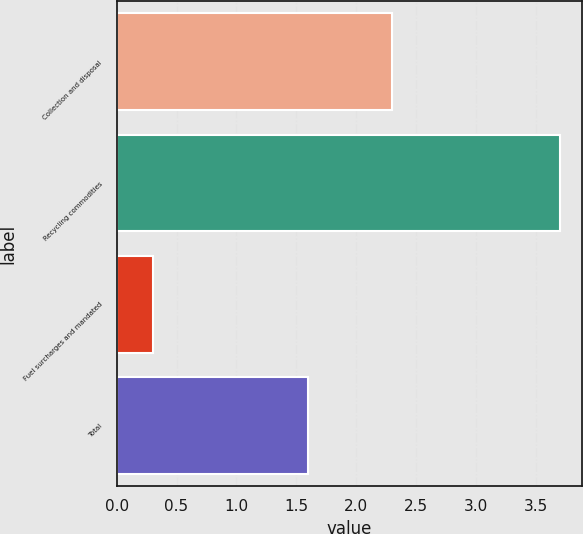Convert chart to OTSL. <chart><loc_0><loc_0><loc_500><loc_500><bar_chart><fcel>Collection and disposal<fcel>Recycling commodities<fcel>Fuel surcharges and mandated<fcel>Total<nl><fcel>2.3<fcel>3.7<fcel>0.3<fcel>1.6<nl></chart> 